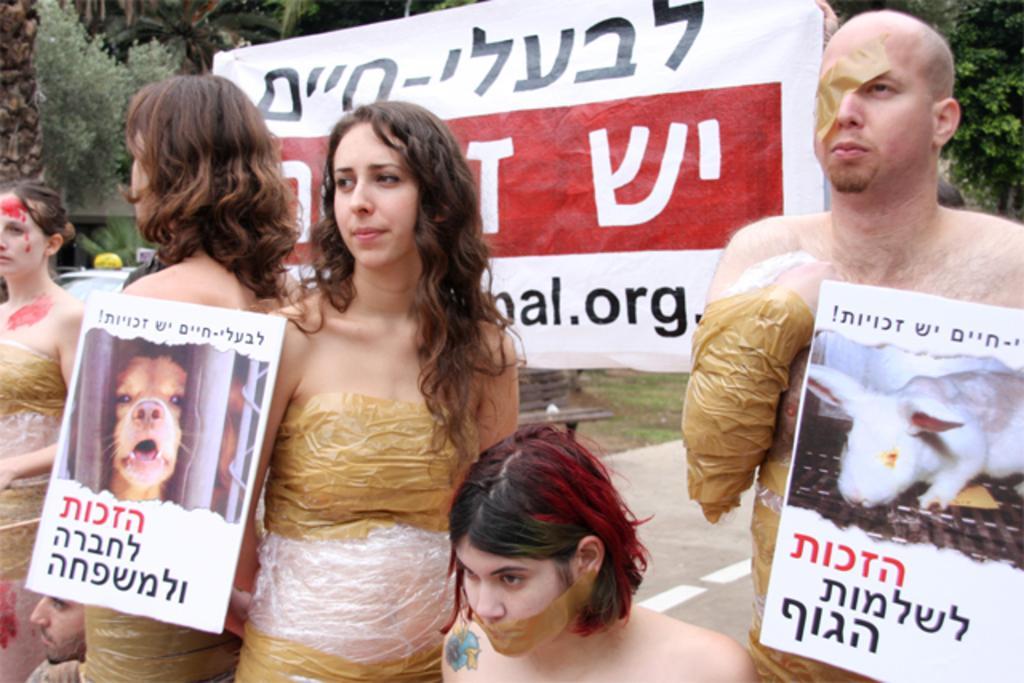Can you describe this image briefly? In this picture I can see few people standing and holding boards, behind there is a banner and some trees. 